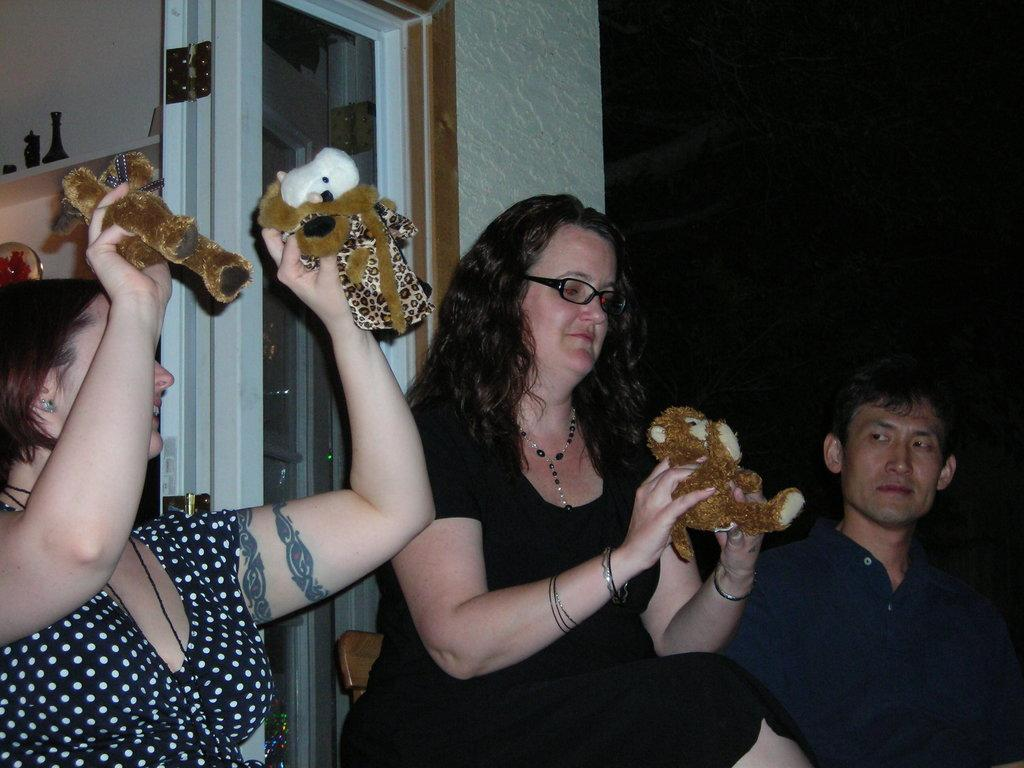How many people are in the image? There are three people in the image: two women and one man. What are the women doing in the image? The women are sitting on chairs and holding a toy. Where is the man located in relation to the women? The man is sitting beside the women. What can be seen in the background of the image? There is a wall in the background of the image, and on that wall, there is a door. What scent is emanating from the toy that the women are holding in the image? There is no information about the scent of the toy in the image, as it is not mentioned in the provided facts. 